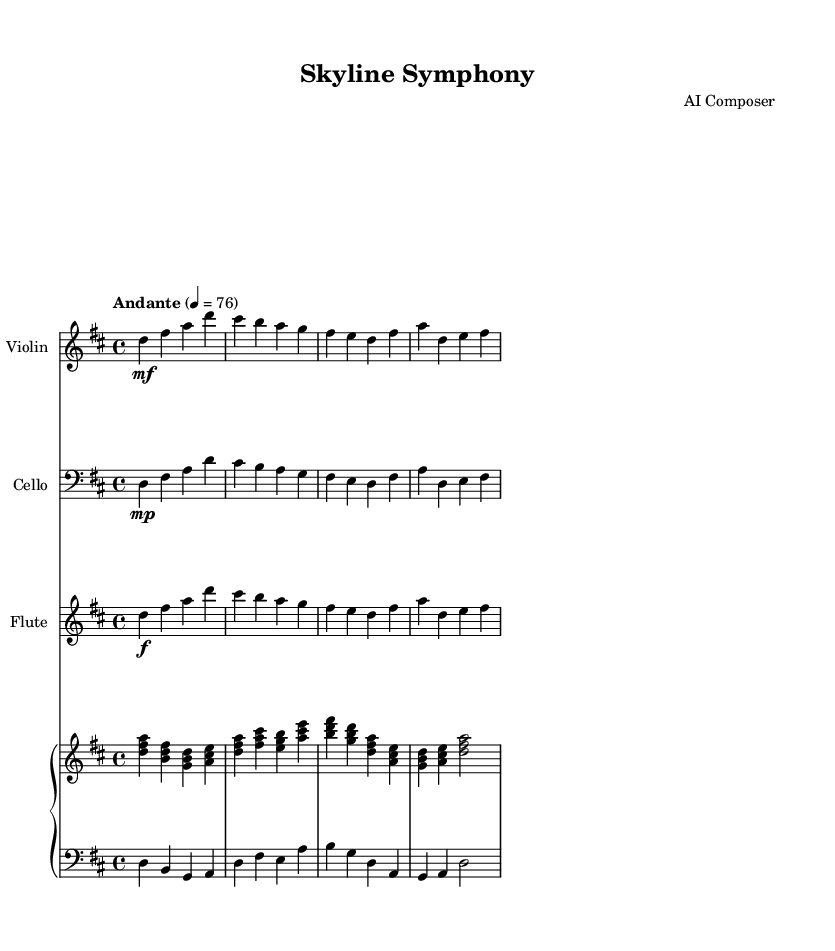What is the key signature of this music? The key signature is indicated by the sharps or flats at the beginning of the staff. In this case, there are two sharps, which indicates the music is in D major.
Answer: D major What is the time signature of this piece? The time signature is shown at the beginning of the staff, represented in the format of beats per measure. Here, it is indicated as 4/4, meaning there are four beats in each measure.
Answer: 4/4 What is the tempo marking of this piece? The tempo marking is typically found just above the staff and indicates the speed of the music. It states "Andante" with a metronome marking of 76, suggesting a moderately slow pace.
Answer: Andante How many instruments are used in this score? By analyzing the score, we can count each separate staff representing different instruments. There are three distinct instruments (Violin, Cello, and Flute) plus the Piano with two staves (right and left).
Answer: Four Which instruments have a dynamic marking of mf? The dynamic marking 'mf' is present immediately on the staff lines where the Violin and Cello parts are written, indicating they are to be played at a medium loud level.
Answer: Violin and Cello In which section of the piece does the dynamics change to f? The dynamic marking changes to 'f' in the Flute part, which occurs right after the first measure, directing the player to play loudly at that moment.
Answer: Flute part How many measures are there in this score? Counting the measures within the score helps us determine the total length of the piece. There are eight measures in this piece overall.
Answer: Eight 